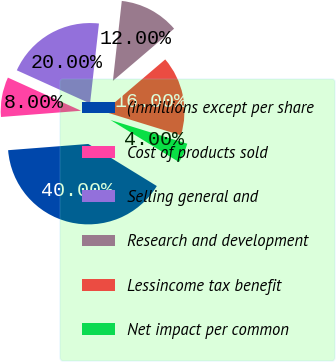Convert chart to OTSL. <chart><loc_0><loc_0><loc_500><loc_500><pie_chart><fcel>(inmillions except per share<fcel>Cost of products sold<fcel>Selling general and<fcel>Research and development<fcel>Lessincome tax benefit<fcel>Net impact per common<nl><fcel>40.0%<fcel>8.0%<fcel>20.0%<fcel>12.0%<fcel>16.0%<fcel>4.0%<nl></chart> 